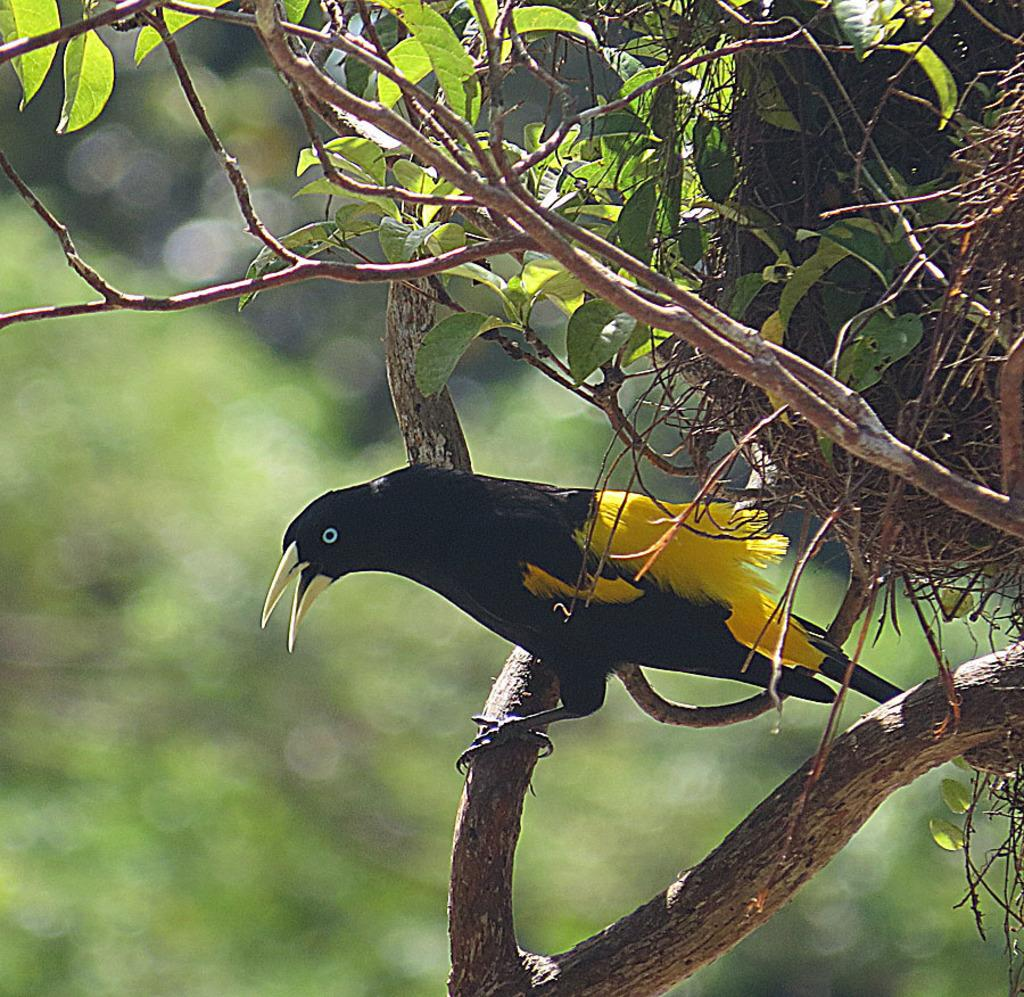What animal can be seen on the tree in the image? There is a bird on the tree in the image. What structure is present on the tree? There is a nest on the tree in the image. How would you describe the background of the image? The background of the image is blurred. What type of list can be seen hanging from the bird's beak in the image? There is no list present in the image; it features a bird on a tree with a nest. 